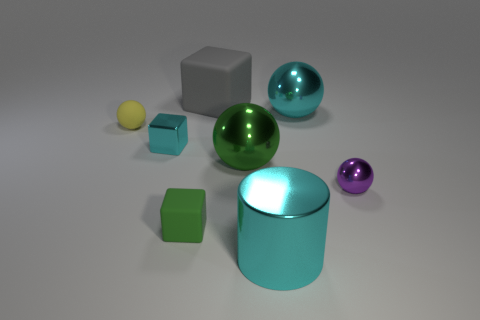The large rubber thing has what color?
Your answer should be compact. Gray. What number of gray balls are there?
Your answer should be compact. 0. What number of big rubber blocks have the same color as the rubber ball?
Offer a very short reply. 0. Does the tiny object that is in front of the tiny purple metallic sphere have the same shape as the cyan shiny object on the right side of the cylinder?
Your answer should be very brief. No. There is a sphere in front of the big ball in front of the metallic thing to the left of the big green metal object; what is its color?
Your answer should be very brief. Purple. The large ball behind the yellow thing is what color?
Provide a succinct answer. Cyan. What color is the metallic block that is the same size as the purple metal thing?
Provide a succinct answer. Cyan. Does the cyan ball have the same size as the cyan cylinder?
Your response must be concise. Yes. There is a small metal sphere; how many tiny yellow objects are in front of it?
Ensure brevity in your answer.  0. What number of objects are blocks on the right side of the tiny cyan block or cyan shiny cubes?
Provide a succinct answer. 3. 